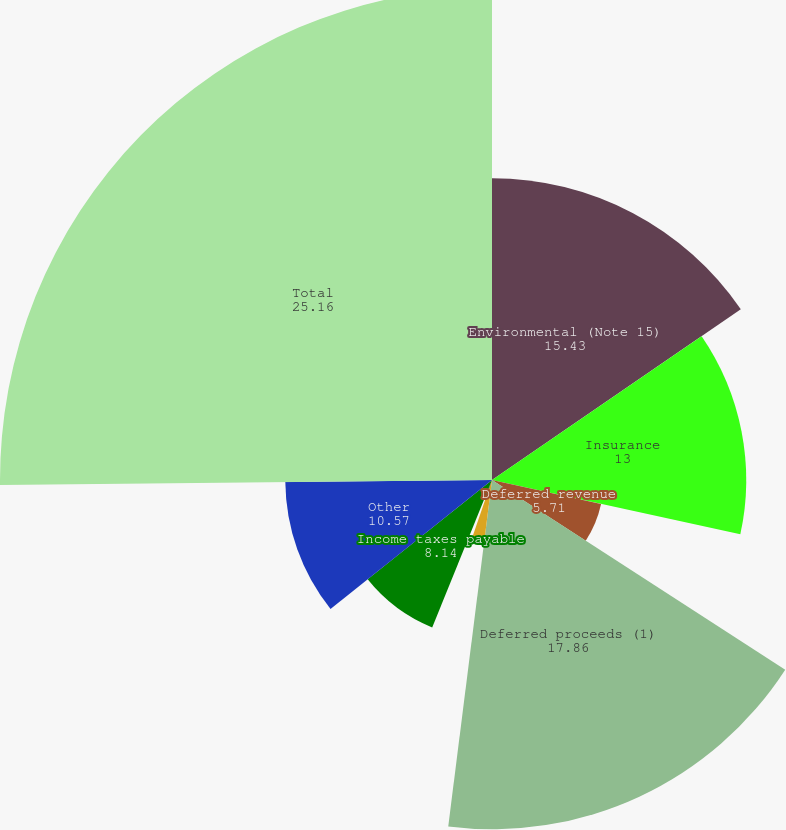Convert chart. <chart><loc_0><loc_0><loc_500><loc_500><pie_chart><fcel>Environmental (Note 15)<fcel>Insurance<fcel>Deferred revenue<fcel>Deferred proceeds (1)<fcel>Asset retirement obligations<fcel>Derivatives (Note 21)<fcel>Income taxes payable<fcel>Other<fcel>Total<nl><fcel>15.43%<fcel>13.0%<fcel>5.71%<fcel>17.86%<fcel>3.28%<fcel>0.85%<fcel>8.14%<fcel>10.57%<fcel>25.16%<nl></chart> 